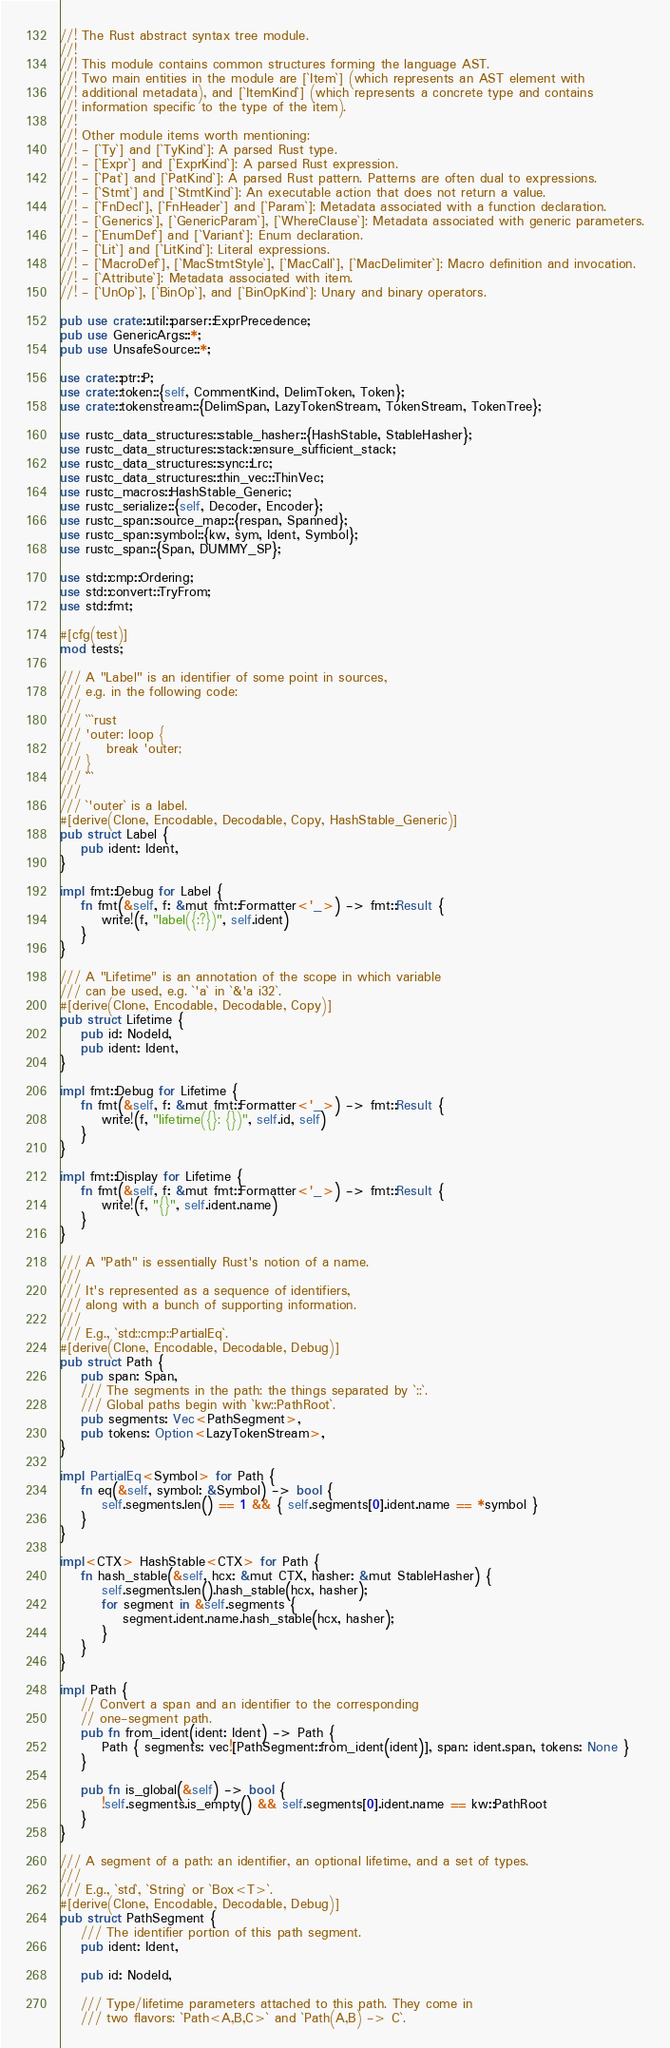Convert code to text. <code><loc_0><loc_0><loc_500><loc_500><_Rust_>//! The Rust abstract syntax tree module.
//!
//! This module contains common structures forming the language AST.
//! Two main entities in the module are [`Item`] (which represents an AST element with
//! additional metadata), and [`ItemKind`] (which represents a concrete type and contains
//! information specific to the type of the item).
//!
//! Other module items worth mentioning:
//! - [`Ty`] and [`TyKind`]: A parsed Rust type.
//! - [`Expr`] and [`ExprKind`]: A parsed Rust expression.
//! - [`Pat`] and [`PatKind`]: A parsed Rust pattern. Patterns are often dual to expressions.
//! - [`Stmt`] and [`StmtKind`]: An executable action that does not return a value.
//! - [`FnDecl`], [`FnHeader`] and [`Param`]: Metadata associated with a function declaration.
//! - [`Generics`], [`GenericParam`], [`WhereClause`]: Metadata associated with generic parameters.
//! - [`EnumDef`] and [`Variant`]: Enum declaration.
//! - [`Lit`] and [`LitKind`]: Literal expressions.
//! - [`MacroDef`], [`MacStmtStyle`], [`MacCall`], [`MacDelimiter`]: Macro definition and invocation.
//! - [`Attribute`]: Metadata associated with item.
//! - [`UnOp`], [`BinOp`], and [`BinOpKind`]: Unary and binary operators.

pub use crate::util::parser::ExprPrecedence;
pub use GenericArgs::*;
pub use UnsafeSource::*;

use crate::ptr::P;
use crate::token::{self, CommentKind, DelimToken, Token};
use crate::tokenstream::{DelimSpan, LazyTokenStream, TokenStream, TokenTree};

use rustc_data_structures::stable_hasher::{HashStable, StableHasher};
use rustc_data_structures::stack::ensure_sufficient_stack;
use rustc_data_structures::sync::Lrc;
use rustc_data_structures::thin_vec::ThinVec;
use rustc_macros::HashStable_Generic;
use rustc_serialize::{self, Decoder, Encoder};
use rustc_span::source_map::{respan, Spanned};
use rustc_span::symbol::{kw, sym, Ident, Symbol};
use rustc_span::{Span, DUMMY_SP};

use std::cmp::Ordering;
use std::convert::TryFrom;
use std::fmt;

#[cfg(test)]
mod tests;

/// A "Label" is an identifier of some point in sources,
/// e.g. in the following code:
///
/// ```rust
/// 'outer: loop {
///     break 'outer;
/// }
/// ```
///
/// `'outer` is a label.
#[derive(Clone, Encodable, Decodable, Copy, HashStable_Generic)]
pub struct Label {
    pub ident: Ident,
}

impl fmt::Debug for Label {
    fn fmt(&self, f: &mut fmt::Formatter<'_>) -> fmt::Result {
        write!(f, "label({:?})", self.ident)
    }
}

/// A "Lifetime" is an annotation of the scope in which variable
/// can be used, e.g. `'a` in `&'a i32`.
#[derive(Clone, Encodable, Decodable, Copy)]
pub struct Lifetime {
    pub id: NodeId,
    pub ident: Ident,
}

impl fmt::Debug for Lifetime {
    fn fmt(&self, f: &mut fmt::Formatter<'_>) -> fmt::Result {
        write!(f, "lifetime({}: {})", self.id, self)
    }
}

impl fmt::Display for Lifetime {
    fn fmt(&self, f: &mut fmt::Formatter<'_>) -> fmt::Result {
        write!(f, "{}", self.ident.name)
    }
}

/// A "Path" is essentially Rust's notion of a name.
///
/// It's represented as a sequence of identifiers,
/// along with a bunch of supporting information.
///
/// E.g., `std::cmp::PartialEq`.
#[derive(Clone, Encodable, Decodable, Debug)]
pub struct Path {
    pub span: Span,
    /// The segments in the path: the things separated by `::`.
    /// Global paths begin with `kw::PathRoot`.
    pub segments: Vec<PathSegment>,
    pub tokens: Option<LazyTokenStream>,
}

impl PartialEq<Symbol> for Path {
    fn eq(&self, symbol: &Symbol) -> bool {
        self.segments.len() == 1 && { self.segments[0].ident.name == *symbol }
    }
}

impl<CTX> HashStable<CTX> for Path {
    fn hash_stable(&self, hcx: &mut CTX, hasher: &mut StableHasher) {
        self.segments.len().hash_stable(hcx, hasher);
        for segment in &self.segments {
            segment.ident.name.hash_stable(hcx, hasher);
        }
    }
}

impl Path {
    // Convert a span and an identifier to the corresponding
    // one-segment path.
    pub fn from_ident(ident: Ident) -> Path {
        Path { segments: vec![PathSegment::from_ident(ident)], span: ident.span, tokens: None }
    }

    pub fn is_global(&self) -> bool {
        !self.segments.is_empty() && self.segments[0].ident.name == kw::PathRoot
    }
}

/// A segment of a path: an identifier, an optional lifetime, and a set of types.
///
/// E.g., `std`, `String` or `Box<T>`.
#[derive(Clone, Encodable, Decodable, Debug)]
pub struct PathSegment {
    /// The identifier portion of this path segment.
    pub ident: Ident,

    pub id: NodeId,

    /// Type/lifetime parameters attached to this path. They come in
    /// two flavors: `Path<A,B,C>` and `Path(A,B) -> C`.</code> 